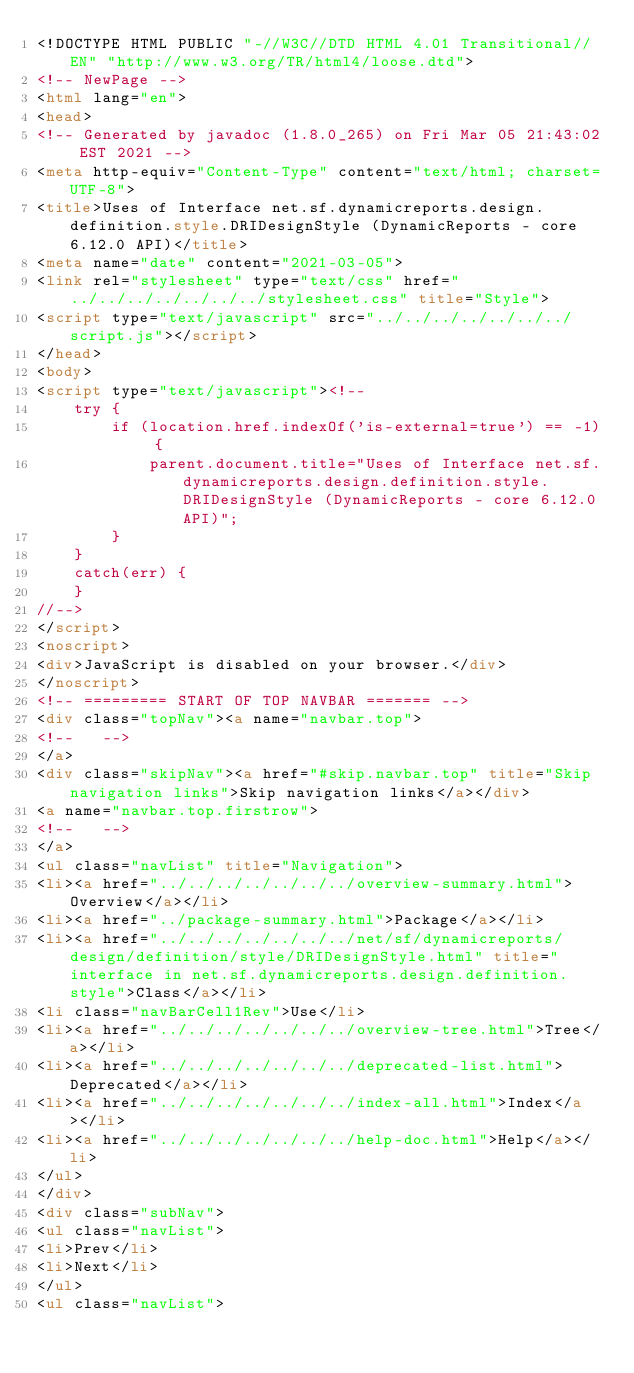<code> <loc_0><loc_0><loc_500><loc_500><_HTML_><!DOCTYPE HTML PUBLIC "-//W3C//DTD HTML 4.01 Transitional//EN" "http://www.w3.org/TR/html4/loose.dtd">
<!-- NewPage -->
<html lang="en">
<head>
<!-- Generated by javadoc (1.8.0_265) on Fri Mar 05 21:43:02 EST 2021 -->
<meta http-equiv="Content-Type" content="text/html; charset=UTF-8">
<title>Uses of Interface net.sf.dynamicreports.design.definition.style.DRIDesignStyle (DynamicReports - core 6.12.0 API)</title>
<meta name="date" content="2021-03-05">
<link rel="stylesheet" type="text/css" href="../../../../../../../stylesheet.css" title="Style">
<script type="text/javascript" src="../../../../../../../script.js"></script>
</head>
<body>
<script type="text/javascript"><!--
    try {
        if (location.href.indexOf('is-external=true') == -1) {
            parent.document.title="Uses of Interface net.sf.dynamicreports.design.definition.style.DRIDesignStyle (DynamicReports - core 6.12.0 API)";
        }
    }
    catch(err) {
    }
//-->
</script>
<noscript>
<div>JavaScript is disabled on your browser.</div>
</noscript>
<!-- ========= START OF TOP NAVBAR ======= -->
<div class="topNav"><a name="navbar.top">
<!--   -->
</a>
<div class="skipNav"><a href="#skip.navbar.top" title="Skip navigation links">Skip navigation links</a></div>
<a name="navbar.top.firstrow">
<!--   -->
</a>
<ul class="navList" title="Navigation">
<li><a href="../../../../../../../overview-summary.html">Overview</a></li>
<li><a href="../package-summary.html">Package</a></li>
<li><a href="../../../../../../../net/sf/dynamicreports/design/definition/style/DRIDesignStyle.html" title="interface in net.sf.dynamicreports.design.definition.style">Class</a></li>
<li class="navBarCell1Rev">Use</li>
<li><a href="../../../../../../../overview-tree.html">Tree</a></li>
<li><a href="../../../../../../../deprecated-list.html">Deprecated</a></li>
<li><a href="../../../../../../../index-all.html">Index</a></li>
<li><a href="../../../../../../../help-doc.html">Help</a></li>
</ul>
</div>
<div class="subNav">
<ul class="navList">
<li>Prev</li>
<li>Next</li>
</ul>
<ul class="navList"></code> 